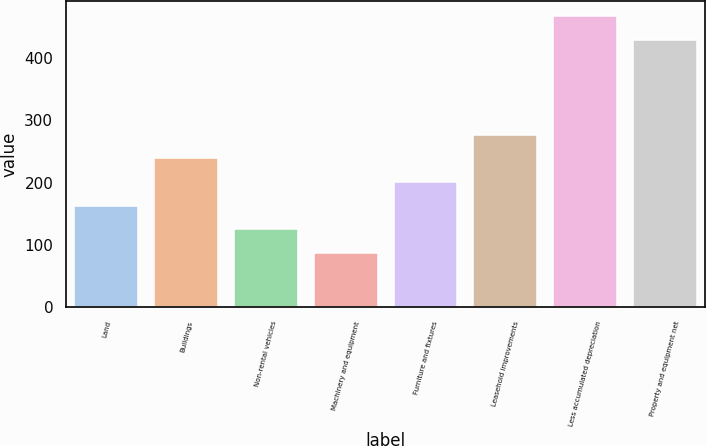Convert chart to OTSL. <chart><loc_0><loc_0><loc_500><loc_500><bar_chart><fcel>Land<fcel>Buildings<fcel>Non-rental vehicles<fcel>Machinery and equipment<fcel>Furniture and fixtures<fcel>Leasehold improvements<fcel>Less accumulated depreciation<fcel>Property and equipment net<nl><fcel>163<fcel>239<fcel>125<fcel>87<fcel>201<fcel>277<fcel>468<fcel>430<nl></chart> 